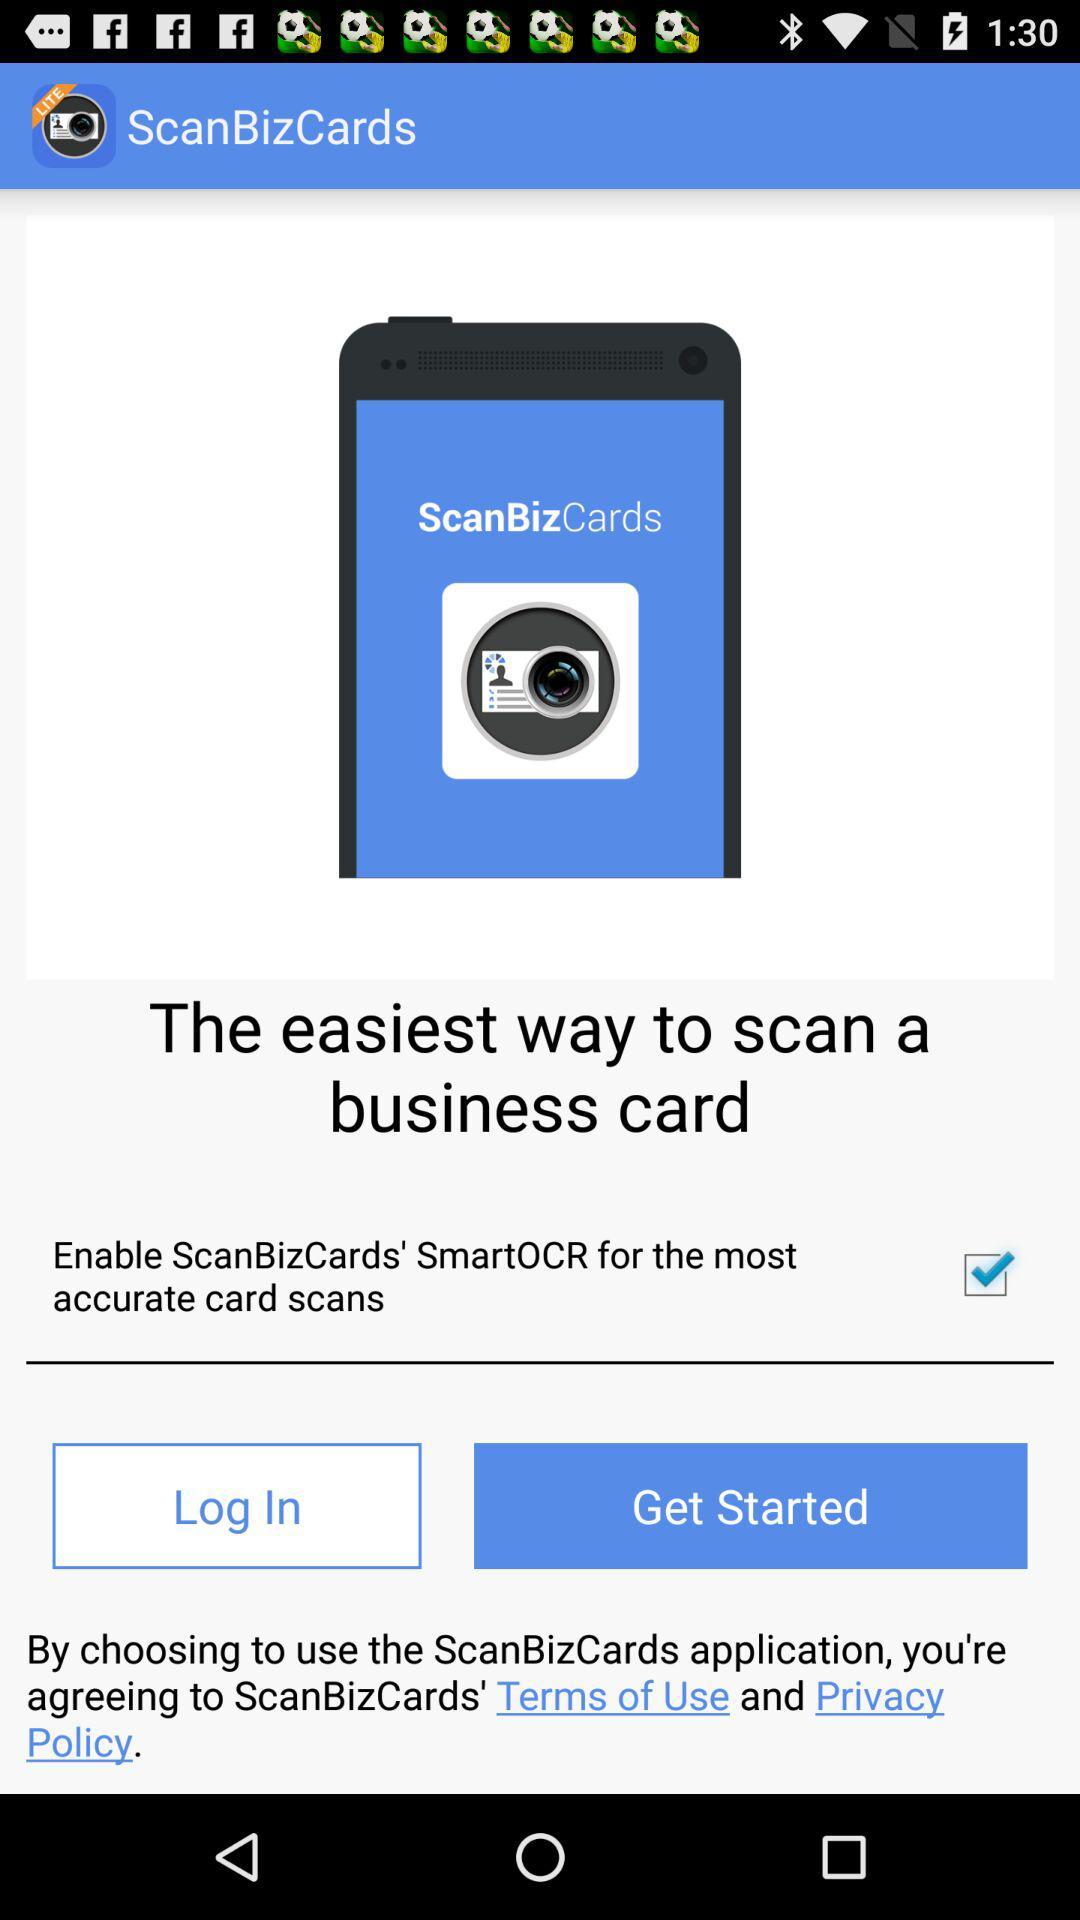What is the application name? The application name is "ScanBizCards". 